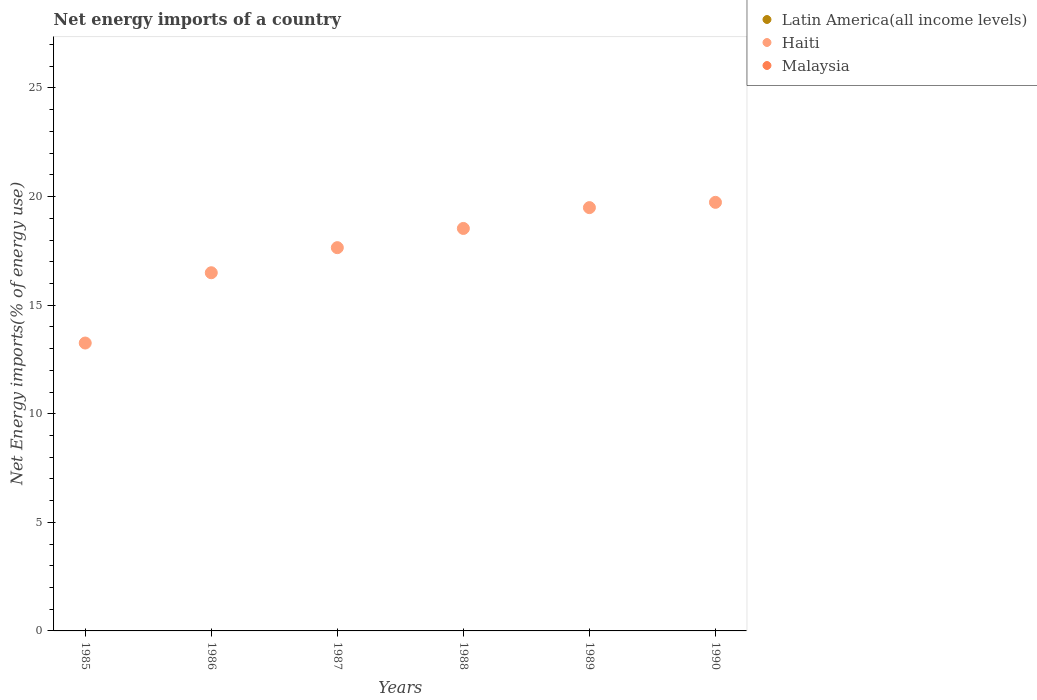Across all years, what is the maximum net energy imports in Haiti?
Give a very brief answer. 19.73. What is the difference between the net energy imports in Haiti in 1986 and that in 1988?
Give a very brief answer. -2.04. What is the difference between the net energy imports in Haiti in 1990 and the net energy imports in Malaysia in 1987?
Provide a succinct answer. 19.73. What is the average net energy imports in Haiti per year?
Keep it short and to the point. 17.53. In how many years, is the net energy imports in Haiti greater than 9 %?
Provide a succinct answer. 6. What is the ratio of the net energy imports in Haiti in 1985 to that in 1987?
Ensure brevity in your answer.  0.75. Is the net energy imports in Haiti in 1986 less than that in 1990?
Provide a short and direct response. Yes. What is the difference between the highest and the second highest net energy imports in Haiti?
Ensure brevity in your answer.  0.24. What is the difference between the highest and the lowest net energy imports in Haiti?
Ensure brevity in your answer.  6.48. Does the net energy imports in Latin America(all income levels) monotonically increase over the years?
Provide a short and direct response. No. Is the net energy imports in Latin America(all income levels) strictly greater than the net energy imports in Haiti over the years?
Ensure brevity in your answer.  No. Is the net energy imports in Haiti strictly less than the net energy imports in Latin America(all income levels) over the years?
Offer a terse response. No. How many dotlines are there?
Your answer should be compact. 1. What is the difference between two consecutive major ticks on the Y-axis?
Your answer should be very brief. 5. Are the values on the major ticks of Y-axis written in scientific E-notation?
Ensure brevity in your answer.  No. Does the graph contain any zero values?
Keep it short and to the point. Yes. Does the graph contain grids?
Your response must be concise. No. How are the legend labels stacked?
Give a very brief answer. Vertical. What is the title of the graph?
Offer a very short reply. Net energy imports of a country. What is the label or title of the X-axis?
Ensure brevity in your answer.  Years. What is the label or title of the Y-axis?
Your response must be concise. Net Energy imports(% of energy use). What is the Net Energy imports(% of energy use) in Haiti in 1985?
Provide a short and direct response. 13.26. What is the Net Energy imports(% of energy use) of Malaysia in 1985?
Your answer should be very brief. 0. What is the Net Energy imports(% of energy use) in Latin America(all income levels) in 1986?
Make the answer very short. 0. What is the Net Energy imports(% of energy use) in Haiti in 1986?
Offer a terse response. 16.49. What is the Net Energy imports(% of energy use) in Malaysia in 1986?
Ensure brevity in your answer.  0. What is the Net Energy imports(% of energy use) in Latin America(all income levels) in 1987?
Offer a very short reply. 0. What is the Net Energy imports(% of energy use) in Haiti in 1987?
Keep it short and to the point. 17.65. What is the Net Energy imports(% of energy use) of Malaysia in 1987?
Make the answer very short. 0. What is the Net Energy imports(% of energy use) of Haiti in 1988?
Offer a terse response. 18.53. What is the Net Energy imports(% of energy use) of Malaysia in 1988?
Provide a succinct answer. 0. What is the Net Energy imports(% of energy use) of Haiti in 1989?
Keep it short and to the point. 19.49. What is the Net Energy imports(% of energy use) of Latin America(all income levels) in 1990?
Ensure brevity in your answer.  0. What is the Net Energy imports(% of energy use) of Haiti in 1990?
Your response must be concise. 19.73. What is the Net Energy imports(% of energy use) of Malaysia in 1990?
Provide a succinct answer. 0. Across all years, what is the maximum Net Energy imports(% of energy use) of Haiti?
Give a very brief answer. 19.73. Across all years, what is the minimum Net Energy imports(% of energy use) in Haiti?
Offer a very short reply. 13.26. What is the total Net Energy imports(% of energy use) in Haiti in the graph?
Provide a short and direct response. 105.15. What is the difference between the Net Energy imports(% of energy use) of Haiti in 1985 and that in 1986?
Your response must be concise. -3.24. What is the difference between the Net Energy imports(% of energy use) in Haiti in 1985 and that in 1987?
Give a very brief answer. -4.39. What is the difference between the Net Energy imports(% of energy use) of Haiti in 1985 and that in 1988?
Your answer should be very brief. -5.28. What is the difference between the Net Energy imports(% of energy use) in Haiti in 1985 and that in 1989?
Your answer should be compact. -6.24. What is the difference between the Net Energy imports(% of energy use) of Haiti in 1985 and that in 1990?
Offer a very short reply. -6.48. What is the difference between the Net Energy imports(% of energy use) of Haiti in 1986 and that in 1987?
Make the answer very short. -1.16. What is the difference between the Net Energy imports(% of energy use) of Haiti in 1986 and that in 1988?
Offer a terse response. -2.04. What is the difference between the Net Energy imports(% of energy use) of Haiti in 1986 and that in 1989?
Ensure brevity in your answer.  -3. What is the difference between the Net Energy imports(% of energy use) in Haiti in 1986 and that in 1990?
Give a very brief answer. -3.24. What is the difference between the Net Energy imports(% of energy use) of Haiti in 1987 and that in 1988?
Ensure brevity in your answer.  -0.88. What is the difference between the Net Energy imports(% of energy use) of Haiti in 1987 and that in 1989?
Offer a very short reply. -1.84. What is the difference between the Net Energy imports(% of energy use) of Haiti in 1987 and that in 1990?
Provide a succinct answer. -2.09. What is the difference between the Net Energy imports(% of energy use) in Haiti in 1988 and that in 1989?
Provide a succinct answer. -0.96. What is the difference between the Net Energy imports(% of energy use) in Haiti in 1988 and that in 1990?
Offer a very short reply. -1.2. What is the difference between the Net Energy imports(% of energy use) in Haiti in 1989 and that in 1990?
Ensure brevity in your answer.  -0.24. What is the average Net Energy imports(% of energy use) in Latin America(all income levels) per year?
Make the answer very short. 0. What is the average Net Energy imports(% of energy use) in Haiti per year?
Give a very brief answer. 17.53. What is the average Net Energy imports(% of energy use) of Malaysia per year?
Make the answer very short. 0. What is the ratio of the Net Energy imports(% of energy use) of Haiti in 1985 to that in 1986?
Provide a succinct answer. 0.8. What is the ratio of the Net Energy imports(% of energy use) of Haiti in 1985 to that in 1987?
Provide a short and direct response. 0.75. What is the ratio of the Net Energy imports(% of energy use) of Haiti in 1985 to that in 1988?
Keep it short and to the point. 0.72. What is the ratio of the Net Energy imports(% of energy use) in Haiti in 1985 to that in 1989?
Offer a very short reply. 0.68. What is the ratio of the Net Energy imports(% of energy use) in Haiti in 1985 to that in 1990?
Provide a short and direct response. 0.67. What is the ratio of the Net Energy imports(% of energy use) of Haiti in 1986 to that in 1987?
Ensure brevity in your answer.  0.93. What is the ratio of the Net Energy imports(% of energy use) in Haiti in 1986 to that in 1988?
Provide a short and direct response. 0.89. What is the ratio of the Net Energy imports(% of energy use) of Haiti in 1986 to that in 1989?
Offer a very short reply. 0.85. What is the ratio of the Net Energy imports(% of energy use) of Haiti in 1986 to that in 1990?
Give a very brief answer. 0.84. What is the ratio of the Net Energy imports(% of energy use) of Haiti in 1987 to that in 1988?
Ensure brevity in your answer.  0.95. What is the ratio of the Net Energy imports(% of energy use) in Haiti in 1987 to that in 1989?
Give a very brief answer. 0.91. What is the ratio of the Net Energy imports(% of energy use) of Haiti in 1987 to that in 1990?
Provide a succinct answer. 0.89. What is the ratio of the Net Energy imports(% of energy use) in Haiti in 1988 to that in 1989?
Your answer should be compact. 0.95. What is the ratio of the Net Energy imports(% of energy use) of Haiti in 1988 to that in 1990?
Offer a very short reply. 0.94. What is the difference between the highest and the second highest Net Energy imports(% of energy use) of Haiti?
Provide a succinct answer. 0.24. What is the difference between the highest and the lowest Net Energy imports(% of energy use) of Haiti?
Keep it short and to the point. 6.48. 